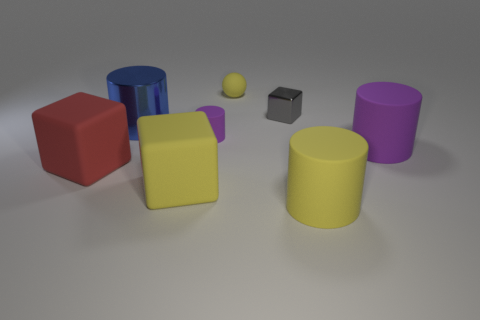Is there anything else that is the same shape as the tiny yellow matte thing?
Ensure brevity in your answer.  No. What number of objects are small matte things that are behind the small cylinder or big things on the right side of the large red cube?
Offer a terse response. 5. Are there more blue things that are in front of the big shiny cylinder than small yellow matte spheres right of the large purple thing?
Provide a succinct answer. No. The small matte object in front of the large shiny object is what color?
Offer a terse response. Purple. Is there another big object of the same shape as the large purple object?
Make the answer very short. Yes. What number of yellow objects are either cylinders or big rubber things?
Make the answer very short. 2. Are there any yellow rubber cylinders that have the same size as the yellow sphere?
Provide a succinct answer. No. How many big brown matte things are there?
Keep it short and to the point. 0. How many small things are either yellow cylinders or matte cylinders?
Provide a short and direct response. 1. What color is the large cylinder on the left side of the matte cylinder behind the purple cylinder to the right of the small yellow object?
Offer a very short reply. Blue. 